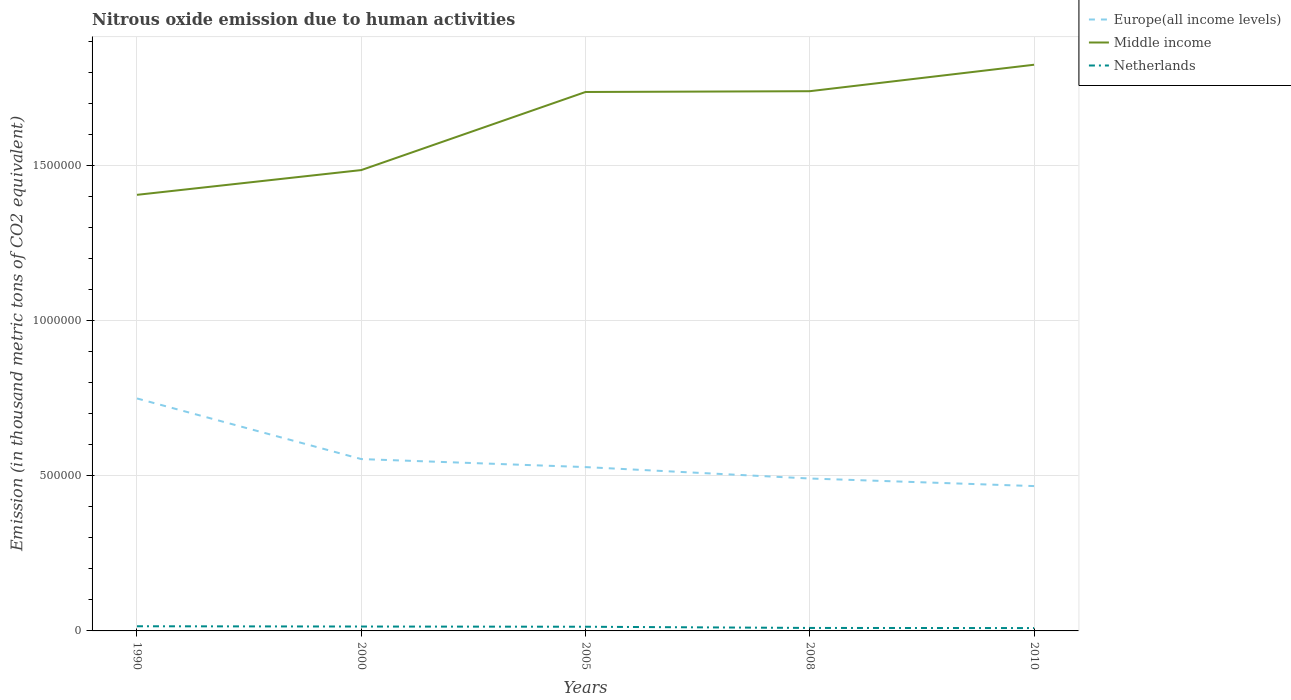Does the line corresponding to Netherlands intersect with the line corresponding to Europe(all income levels)?
Your answer should be very brief. No. Is the number of lines equal to the number of legend labels?
Your answer should be compact. Yes. Across all years, what is the maximum amount of nitrous oxide emitted in Europe(all income levels)?
Offer a very short reply. 4.67e+05. In which year was the amount of nitrous oxide emitted in Europe(all income levels) maximum?
Keep it short and to the point. 2010. What is the total amount of nitrous oxide emitted in Middle income in the graph?
Ensure brevity in your answer.  -3.34e+05. What is the difference between the highest and the second highest amount of nitrous oxide emitted in Middle income?
Give a very brief answer. 4.19e+05. What is the difference between two consecutive major ticks on the Y-axis?
Offer a terse response. 5.00e+05. Does the graph contain any zero values?
Your answer should be very brief. No. Where does the legend appear in the graph?
Give a very brief answer. Top right. What is the title of the graph?
Offer a very short reply. Nitrous oxide emission due to human activities. Does "Bhutan" appear as one of the legend labels in the graph?
Provide a succinct answer. No. What is the label or title of the X-axis?
Your answer should be very brief. Years. What is the label or title of the Y-axis?
Give a very brief answer. Emission (in thousand metric tons of CO2 equivalent). What is the Emission (in thousand metric tons of CO2 equivalent) in Europe(all income levels) in 1990?
Ensure brevity in your answer.  7.49e+05. What is the Emission (in thousand metric tons of CO2 equivalent) of Middle income in 1990?
Provide a short and direct response. 1.41e+06. What is the Emission (in thousand metric tons of CO2 equivalent) of Netherlands in 1990?
Your answer should be very brief. 1.50e+04. What is the Emission (in thousand metric tons of CO2 equivalent) of Europe(all income levels) in 2000?
Keep it short and to the point. 5.54e+05. What is the Emission (in thousand metric tons of CO2 equivalent) of Middle income in 2000?
Give a very brief answer. 1.49e+06. What is the Emission (in thousand metric tons of CO2 equivalent) of Netherlands in 2000?
Make the answer very short. 1.42e+04. What is the Emission (in thousand metric tons of CO2 equivalent) of Europe(all income levels) in 2005?
Offer a very short reply. 5.28e+05. What is the Emission (in thousand metric tons of CO2 equivalent) in Middle income in 2005?
Your response must be concise. 1.74e+06. What is the Emission (in thousand metric tons of CO2 equivalent) in Netherlands in 2005?
Give a very brief answer. 1.35e+04. What is the Emission (in thousand metric tons of CO2 equivalent) in Europe(all income levels) in 2008?
Your answer should be very brief. 4.91e+05. What is the Emission (in thousand metric tons of CO2 equivalent) of Middle income in 2008?
Keep it short and to the point. 1.74e+06. What is the Emission (in thousand metric tons of CO2 equivalent) in Netherlands in 2008?
Keep it short and to the point. 9594.2. What is the Emission (in thousand metric tons of CO2 equivalent) of Europe(all income levels) in 2010?
Make the answer very short. 4.67e+05. What is the Emission (in thousand metric tons of CO2 equivalent) of Middle income in 2010?
Your answer should be very brief. 1.82e+06. What is the Emission (in thousand metric tons of CO2 equivalent) in Netherlands in 2010?
Provide a succinct answer. 9204.6. Across all years, what is the maximum Emission (in thousand metric tons of CO2 equivalent) of Europe(all income levels)?
Offer a very short reply. 7.49e+05. Across all years, what is the maximum Emission (in thousand metric tons of CO2 equivalent) of Middle income?
Your answer should be compact. 1.82e+06. Across all years, what is the maximum Emission (in thousand metric tons of CO2 equivalent) in Netherlands?
Provide a short and direct response. 1.50e+04. Across all years, what is the minimum Emission (in thousand metric tons of CO2 equivalent) in Europe(all income levels)?
Make the answer very short. 4.67e+05. Across all years, what is the minimum Emission (in thousand metric tons of CO2 equivalent) in Middle income?
Offer a terse response. 1.41e+06. Across all years, what is the minimum Emission (in thousand metric tons of CO2 equivalent) in Netherlands?
Give a very brief answer. 9204.6. What is the total Emission (in thousand metric tons of CO2 equivalent) in Europe(all income levels) in the graph?
Offer a terse response. 2.79e+06. What is the total Emission (in thousand metric tons of CO2 equivalent) of Middle income in the graph?
Give a very brief answer. 8.19e+06. What is the total Emission (in thousand metric tons of CO2 equivalent) of Netherlands in the graph?
Give a very brief answer. 6.15e+04. What is the difference between the Emission (in thousand metric tons of CO2 equivalent) of Europe(all income levels) in 1990 and that in 2000?
Your answer should be compact. 1.95e+05. What is the difference between the Emission (in thousand metric tons of CO2 equivalent) in Middle income in 1990 and that in 2000?
Make the answer very short. -7.98e+04. What is the difference between the Emission (in thousand metric tons of CO2 equivalent) in Netherlands in 1990 and that in 2000?
Make the answer very short. 863.2. What is the difference between the Emission (in thousand metric tons of CO2 equivalent) of Europe(all income levels) in 1990 and that in 2005?
Provide a short and direct response. 2.21e+05. What is the difference between the Emission (in thousand metric tons of CO2 equivalent) in Middle income in 1990 and that in 2005?
Ensure brevity in your answer.  -3.31e+05. What is the difference between the Emission (in thousand metric tons of CO2 equivalent) of Netherlands in 1990 and that in 2005?
Provide a short and direct response. 1544.5. What is the difference between the Emission (in thousand metric tons of CO2 equivalent) of Europe(all income levels) in 1990 and that in 2008?
Offer a terse response. 2.58e+05. What is the difference between the Emission (in thousand metric tons of CO2 equivalent) of Middle income in 1990 and that in 2008?
Your answer should be compact. -3.34e+05. What is the difference between the Emission (in thousand metric tons of CO2 equivalent) in Netherlands in 1990 and that in 2008?
Offer a terse response. 5431.1. What is the difference between the Emission (in thousand metric tons of CO2 equivalent) of Europe(all income levels) in 1990 and that in 2010?
Your answer should be compact. 2.82e+05. What is the difference between the Emission (in thousand metric tons of CO2 equivalent) of Middle income in 1990 and that in 2010?
Provide a succinct answer. -4.19e+05. What is the difference between the Emission (in thousand metric tons of CO2 equivalent) of Netherlands in 1990 and that in 2010?
Provide a succinct answer. 5820.7. What is the difference between the Emission (in thousand metric tons of CO2 equivalent) of Europe(all income levels) in 2000 and that in 2005?
Keep it short and to the point. 2.58e+04. What is the difference between the Emission (in thousand metric tons of CO2 equivalent) in Middle income in 2000 and that in 2005?
Keep it short and to the point. -2.52e+05. What is the difference between the Emission (in thousand metric tons of CO2 equivalent) in Netherlands in 2000 and that in 2005?
Ensure brevity in your answer.  681.3. What is the difference between the Emission (in thousand metric tons of CO2 equivalent) in Europe(all income levels) in 2000 and that in 2008?
Give a very brief answer. 6.26e+04. What is the difference between the Emission (in thousand metric tons of CO2 equivalent) in Middle income in 2000 and that in 2008?
Provide a succinct answer. -2.54e+05. What is the difference between the Emission (in thousand metric tons of CO2 equivalent) in Netherlands in 2000 and that in 2008?
Offer a very short reply. 4567.9. What is the difference between the Emission (in thousand metric tons of CO2 equivalent) in Europe(all income levels) in 2000 and that in 2010?
Make the answer very short. 8.70e+04. What is the difference between the Emission (in thousand metric tons of CO2 equivalent) of Middle income in 2000 and that in 2010?
Ensure brevity in your answer.  -3.39e+05. What is the difference between the Emission (in thousand metric tons of CO2 equivalent) of Netherlands in 2000 and that in 2010?
Make the answer very short. 4957.5. What is the difference between the Emission (in thousand metric tons of CO2 equivalent) of Europe(all income levels) in 2005 and that in 2008?
Make the answer very short. 3.68e+04. What is the difference between the Emission (in thousand metric tons of CO2 equivalent) in Middle income in 2005 and that in 2008?
Your answer should be compact. -2525.2. What is the difference between the Emission (in thousand metric tons of CO2 equivalent) in Netherlands in 2005 and that in 2008?
Provide a short and direct response. 3886.6. What is the difference between the Emission (in thousand metric tons of CO2 equivalent) in Europe(all income levels) in 2005 and that in 2010?
Make the answer very short. 6.12e+04. What is the difference between the Emission (in thousand metric tons of CO2 equivalent) in Middle income in 2005 and that in 2010?
Offer a very short reply. -8.78e+04. What is the difference between the Emission (in thousand metric tons of CO2 equivalent) of Netherlands in 2005 and that in 2010?
Give a very brief answer. 4276.2. What is the difference between the Emission (in thousand metric tons of CO2 equivalent) in Europe(all income levels) in 2008 and that in 2010?
Your answer should be very brief. 2.44e+04. What is the difference between the Emission (in thousand metric tons of CO2 equivalent) in Middle income in 2008 and that in 2010?
Keep it short and to the point. -8.53e+04. What is the difference between the Emission (in thousand metric tons of CO2 equivalent) in Netherlands in 2008 and that in 2010?
Your response must be concise. 389.6. What is the difference between the Emission (in thousand metric tons of CO2 equivalent) of Europe(all income levels) in 1990 and the Emission (in thousand metric tons of CO2 equivalent) of Middle income in 2000?
Give a very brief answer. -7.36e+05. What is the difference between the Emission (in thousand metric tons of CO2 equivalent) of Europe(all income levels) in 1990 and the Emission (in thousand metric tons of CO2 equivalent) of Netherlands in 2000?
Provide a succinct answer. 7.35e+05. What is the difference between the Emission (in thousand metric tons of CO2 equivalent) in Middle income in 1990 and the Emission (in thousand metric tons of CO2 equivalent) in Netherlands in 2000?
Give a very brief answer. 1.39e+06. What is the difference between the Emission (in thousand metric tons of CO2 equivalent) of Europe(all income levels) in 1990 and the Emission (in thousand metric tons of CO2 equivalent) of Middle income in 2005?
Your response must be concise. -9.88e+05. What is the difference between the Emission (in thousand metric tons of CO2 equivalent) of Europe(all income levels) in 1990 and the Emission (in thousand metric tons of CO2 equivalent) of Netherlands in 2005?
Your response must be concise. 7.36e+05. What is the difference between the Emission (in thousand metric tons of CO2 equivalent) of Middle income in 1990 and the Emission (in thousand metric tons of CO2 equivalent) of Netherlands in 2005?
Provide a short and direct response. 1.39e+06. What is the difference between the Emission (in thousand metric tons of CO2 equivalent) of Europe(all income levels) in 1990 and the Emission (in thousand metric tons of CO2 equivalent) of Middle income in 2008?
Keep it short and to the point. -9.90e+05. What is the difference between the Emission (in thousand metric tons of CO2 equivalent) in Europe(all income levels) in 1990 and the Emission (in thousand metric tons of CO2 equivalent) in Netherlands in 2008?
Provide a short and direct response. 7.40e+05. What is the difference between the Emission (in thousand metric tons of CO2 equivalent) of Middle income in 1990 and the Emission (in thousand metric tons of CO2 equivalent) of Netherlands in 2008?
Your response must be concise. 1.40e+06. What is the difference between the Emission (in thousand metric tons of CO2 equivalent) of Europe(all income levels) in 1990 and the Emission (in thousand metric tons of CO2 equivalent) of Middle income in 2010?
Provide a succinct answer. -1.08e+06. What is the difference between the Emission (in thousand metric tons of CO2 equivalent) in Europe(all income levels) in 1990 and the Emission (in thousand metric tons of CO2 equivalent) in Netherlands in 2010?
Offer a terse response. 7.40e+05. What is the difference between the Emission (in thousand metric tons of CO2 equivalent) in Middle income in 1990 and the Emission (in thousand metric tons of CO2 equivalent) in Netherlands in 2010?
Make the answer very short. 1.40e+06. What is the difference between the Emission (in thousand metric tons of CO2 equivalent) of Europe(all income levels) in 2000 and the Emission (in thousand metric tons of CO2 equivalent) of Middle income in 2005?
Provide a succinct answer. -1.18e+06. What is the difference between the Emission (in thousand metric tons of CO2 equivalent) of Europe(all income levels) in 2000 and the Emission (in thousand metric tons of CO2 equivalent) of Netherlands in 2005?
Provide a short and direct response. 5.40e+05. What is the difference between the Emission (in thousand metric tons of CO2 equivalent) in Middle income in 2000 and the Emission (in thousand metric tons of CO2 equivalent) in Netherlands in 2005?
Offer a terse response. 1.47e+06. What is the difference between the Emission (in thousand metric tons of CO2 equivalent) in Europe(all income levels) in 2000 and the Emission (in thousand metric tons of CO2 equivalent) in Middle income in 2008?
Make the answer very short. -1.19e+06. What is the difference between the Emission (in thousand metric tons of CO2 equivalent) of Europe(all income levels) in 2000 and the Emission (in thousand metric tons of CO2 equivalent) of Netherlands in 2008?
Your answer should be compact. 5.44e+05. What is the difference between the Emission (in thousand metric tons of CO2 equivalent) of Middle income in 2000 and the Emission (in thousand metric tons of CO2 equivalent) of Netherlands in 2008?
Your answer should be very brief. 1.48e+06. What is the difference between the Emission (in thousand metric tons of CO2 equivalent) of Europe(all income levels) in 2000 and the Emission (in thousand metric tons of CO2 equivalent) of Middle income in 2010?
Give a very brief answer. -1.27e+06. What is the difference between the Emission (in thousand metric tons of CO2 equivalent) of Europe(all income levels) in 2000 and the Emission (in thousand metric tons of CO2 equivalent) of Netherlands in 2010?
Offer a very short reply. 5.45e+05. What is the difference between the Emission (in thousand metric tons of CO2 equivalent) of Middle income in 2000 and the Emission (in thousand metric tons of CO2 equivalent) of Netherlands in 2010?
Give a very brief answer. 1.48e+06. What is the difference between the Emission (in thousand metric tons of CO2 equivalent) in Europe(all income levels) in 2005 and the Emission (in thousand metric tons of CO2 equivalent) in Middle income in 2008?
Your answer should be compact. -1.21e+06. What is the difference between the Emission (in thousand metric tons of CO2 equivalent) of Europe(all income levels) in 2005 and the Emission (in thousand metric tons of CO2 equivalent) of Netherlands in 2008?
Offer a very short reply. 5.18e+05. What is the difference between the Emission (in thousand metric tons of CO2 equivalent) in Middle income in 2005 and the Emission (in thousand metric tons of CO2 equivalent) in Netherlands in 2008?
Make the answer very short. 1.73e+06. What is the difference between the Emission (in thousand metric tons of CO2 equivalent) in Europe(all income levels) in 2005 and the Emission (in thousand metric tons of CO2 equivalent) in Middle income in 2010?
Offer a terse response. -1.30e+06. What is the difference between the Emission (in thousand metric tons of CO2 equivalent) of Europe(all income levels) in 2005 and the Emission (in thousand metric tons of CO2 equivalent) of Netherlands in 2010?
Your answer should be compact. 5.19e+05. What is the difference between the Emission (in thousand metric tons of CO2 equivalent) in Middle income in 2005 and the Emission (in thousand metric tons of CO2 equivalent) in Netherlands in 2010?
Offer a terse response. 1.73e+06. What is the difference between the Emission (in thousand metric tons of CO2 equivalent) in Europe(all income levels) in 2008 and the Emission (in thousand metric tons of CO2 equivalent) in Middle income in 2010?
Make the answer very short. -1.33e+06. What is the difference between the Emission (in thousand metric tons of CO2 equivalent) in Europe(all income levels) in 2008 and the Emission (in thousand metric tons of CO2 equivalent) in Netherlands in 2010?
Offer a very short reply. 4.82e+05. What is the difference between the Emission (in thousand metric tons of CO2 equivalent) in Middle income in 2008 and the Emission (in thousand metric tons of CO2 equivalent) in Netherlands in 2010?
Make the answer very short. 1.73e+06. What is the average Emission (in thousand metric tons of CO2 equivalent) in Europe(all income levels) per year?
Provide a succinct answer. 5.58e+05. What is the average Emission (in thousand metric tons of CO2 equivalent) in Middle income per year?
Your answer should be compact. 1.64e+06. What is the average Emission (in thousand metric tons of CO2 equivalent) of Netherlands per year?
Offer a terse response. 1.23e+04. In the year 1990, what is the difference between the Emission (in thousand metric tons of CO2 equivalent) in Europe(all income levels) and Emission (in thousand metric tons of CO2 equivalent) in Middle income?
Your answer should be compact. -6.56e+05. In the year 1990, what is the difference between the Emission (in thousand metric tons of CO2 equivalent) in Europe(all income levels) and Emission (in thousand metric tons of CO2 equivalent) in Netherlands?
Make the answer very short. 7.34e+05. In the year 1990, what is the difference between the Emission (in thousand metric tons of CO2 equivalent) in Middle income and Emission (in thousand metric tons of CO2 equivalent) in Netherlands?
Provide a succinct answer. 1.39e+06. In the year 2000, what is the difference between the Emission (in thousand metric tons of CO2 equivalent) of Europe(all income levels) and Emission (in thousand metric tons of CO2 equivalent) of Middle income?
Provide a succinct answer. -9.31e+05. In the year 2000, what is the difference between the Emission (in thousand metric tons of CO2 equivalent) in Europe(all income levels) and Emission (in thousand metric tons of CO2 equivalent) in Netherlands?
Provide a short and direct response. 5.40e+05. In the year 2000, what is the difference between the Emission (in thousand metric tons of CO2 equivalent) of Middle income and Emission (in thousand metric tons of CO2 equivalent) of Netherlands?
Your answer should be very brief. 1.47e+06. In the year 2005, what is the difference between the Emission (in thousand metric tons of CO2 equivalent) of Europe(all income levels) and Emission (in thousand metric tons of CO2 equivalent) of Middle income?
Ensure brevity in your answer.  -1.21e+06. In the year 2005, what is the difference between the Emission (in thousand metric tons of CO2 equivalent) in Europe(all income levels) and Emission (in thousand metric tons of CO2 equivalent) in Netherlands?
Keep it short and to the point. 5.14e+05. In the year 2005, what is the difference between the Emission (in thousand metric tons of CO2 equivalent) in Middle income and Emission (in thousand metric tons of CO2 equivalent) in Netherlands?
Ensure brevity in your answer.  1.72e+06. In the year 2008, what is the difference between the Emission (in thousand metric tons of CO2 equivalent) of Europe(all income levels) and Emission (in thousand metric tons of CO2 equivalent) of Middle income?
Make the answer very short. -1.25e+06. In the year 2008, what is the difference between the Emission (in thousand metric tons of CO2 equivalent) of Europe(all income levels) and Emission (in thousand metric tons of CO2 equivalent) of Netherlands?
Give a very brief answer. 4.82e+05. In the year 2008, what is the difference between the Emission (in thousand metric tons of CO2 equivalent) of Middle income and Emission (in thousand metric tons of CO2 equivalent) of Netherlands?
Provide a short and direct response. 1.73e+06. In the year 2010, what is the difference between the Emission (in thousand metric tons of CO2 equivalent) of Europe(all income levels) and Emission (in thousand metric tons of CO2 equivalent) of Middle income?
Offer a terse response. -1.36e+06. In the year 2010, what is the difference between the Emission (in thousand metric tons of CO2 equivalent) in Europe(all income levels) and Emission (in thousand metric tons of CO2 equivalent) in Netherlands?
Give a very brief answer. 4.58e+05. In the year 2010, what is the difference between the Emission (in thousand metric tons of CO2 equivalent) of Middle income and Emission (in thousand metric tons of CO2 equivalent) of Netherlands?
Offer a terse response. 1.82e+06. What is the ratio of the Emission (in thousand metric tons of CO2 equivalent) of Europe(all income levels) in 1990 to that in 2000?
Keep it short and to the point. 1.35. What is the ratio of the Emission (in thousand metric tons of CO2 equivalent) of Middle income in 1990 to that in 2000?
Make the answer very short. 0.95. What is the ratio of the Emission (in thousand metric tons of CO2 equivalent) of Netherlands in 1990 to that in 2000?
Offer a terse response. 1.06. What is the ratio of the Emission (in thousand metric tons of CO2 equivalent) of Europe(all income levels) in 1990 to that in 2005?
Provide a short and direct response. 1.42. What is the ratio of the Emission (in thousand metric tons of CO2 equivalent) of Middle income in 1990 to that in 2005?
Keep it short and to the point. 0.81. What is the ratio of the Emission (in thousand metric tons of CO2 equivalent) of Netherlands in 1990 to that in 2005?
Give a very brief answer. 1.11. What is the ratio of the Emission (in thousand metric tons of CO2 equivalent) in Europe(all income levels) in 1990 to that in 2008?
Your response must be concise. 1.53. What is the ratio of the Emission (in thousand metric tons of CO2 equivalent) in Middle income in 1990 to that in 2008?
Ensure brevity in your answer.  0.81. What is the ratio of the Emission (in thousand metric tons of CO2 equivalent) of Netherlands in 1990 to that in 2008?
Your answer should be compact. 1.57. What is the ratio of the Emission (in thousand metric tons of CO2 equivalent) of Europe(all income levels) in 1990 to that in 2010?
Make the answer very short. 1.6. What is the ratio of the Emission (in thousand metric tons of CO2 equivalent) in Middle income in 1990 to that in 2010?
Provide a succinct answer. 0.77. What is the ratio of the Emission (in thousand metric tons of CO2 equivalent) in Netherlands in 1990 to that in 2010?
Keep it short and to the point. 1.63. What is the ratio of the Emission (in thousand metric tons of CO2 equivalent) in Europe(all income levels) in 2000 to that in 2005?
Your answer should be very brief. 1.05. What is the ratio of the Emission (in thousand metric tons of CO2 equivalent) in Middle income in 2000 to that in 2005?
Provide a short and direct response. 0.86. What is the ratio of the Emission (in thousand metric tons of CO2 equivalent) of Netherlands in 2000 to that in 2005?
Your answer should be compact. 1.05. What is the ratio of the Emission (in thousand metric tons of CO2 equivalent) of Europe(all income levels) in 2000 to that in 2008?
Ensure brevity in your answer.  1.13. What is the ratio of the Emission (in thousand metric tons of CO2 equivalent) in Middle income in 2000 to that in 2008?
Offer a very short reply. 0.85. What is the ratio of the Emission (in thousand metric tons of CO2 equivalent) of Netherlands in 2000 to that in 2008?
Keep it short and to the point. 1.48. What is the ratio of the Emission (in thousand metric tons of CO2 equivalent) of Europe(all income levels) in 2000 to that in 2010?
Provide a short and direct response. 1.19. What is the ratio of the Emission (in thousand metric tons of CO2 equivalent) of Middle income in 2000 to that in 2010?
Keep it short and to the point. 0.81. What is the ratio of the Emission (in thousand metric tons of CO2 equivalent) in Netherlands in 2000 to that in 2010?
Make the answer very short. 1.54. What is the ratio of the Emission (in thousand metric tons of CO2 equivalent) of Europe(all income levels) in 2005 to that in 2008?
Give a very brief answer. 1.07. What is the ratio of the Emission (in thousand metric tons of CO2 equivalent) in Netherlands in 2005 to that in 2008?
Make the answer very short. 1.41. What is the ratio of the Emission (in thousand metric tons of CO2 equivalent) in Europe(all income levels) in 2005 to that in 2010?
Your response must be concise. 1.13. What is the ratio of the Emission (in thousand metric tons of CO2 equivalent) of Middle income in 2005 to that in 2010?
Your answer should be very brief. 0.95. What is the ratio of the Emission (in thousand metric tons of CO2 equivalent) in Netherlands in 2005 to that in 2010?
Provide a short and direct response. 1.46. What is the ratio of the Emission (in thousand metric tons of CO2 equivalent) in Europe(all income levels) in 2008 to that in 2010?
Offer a very short reply. 1.05. What is the ratio of the Emission (in thousand metric tons of CO2 equivalent) in Middle income in 2008 to that in 2010?
Ensure brevity in your answer.  0.95. What is the ratio of the Emission (in thousand metric tons of CO2 equivalent) in Netherlands in 2008 to that in 2010?
Give a very brief answer. 1.04. What is the difference between the highest and the second highest Emission (in thousand metric tons of CO2 equivalent) of Europe(all income levels)?
Your answer should be compact. 1.95e+05. What is the difference between the highest and the second highest Emission (in thousand metric tons of CO2 equivalent) of Middle income?
Your response must be concise. 8.53e+04. What is the difference between the highest and the second highest Emission (in thousand metric tons of CO2 equivalent) in Netherlands?
Offer a terse response. 863.2. What is the difference between the highest and the lowest Emission (in thousand metric tons of CO2 equivalent) of Europe(all income levels)?
Your answer should be very brief. 2.82e+05. What is the difference between the highest and the lowest Emission (in thousand metric tons of CO2 equivalent) of Middle income?
Keep it short and to the point. 4.19e+05. What is the difference between the highest and the lowest Emission (in thousand metric tons of CO2 equivalent) of Netherlands?
Provide a succinct answer. 5820.7. 